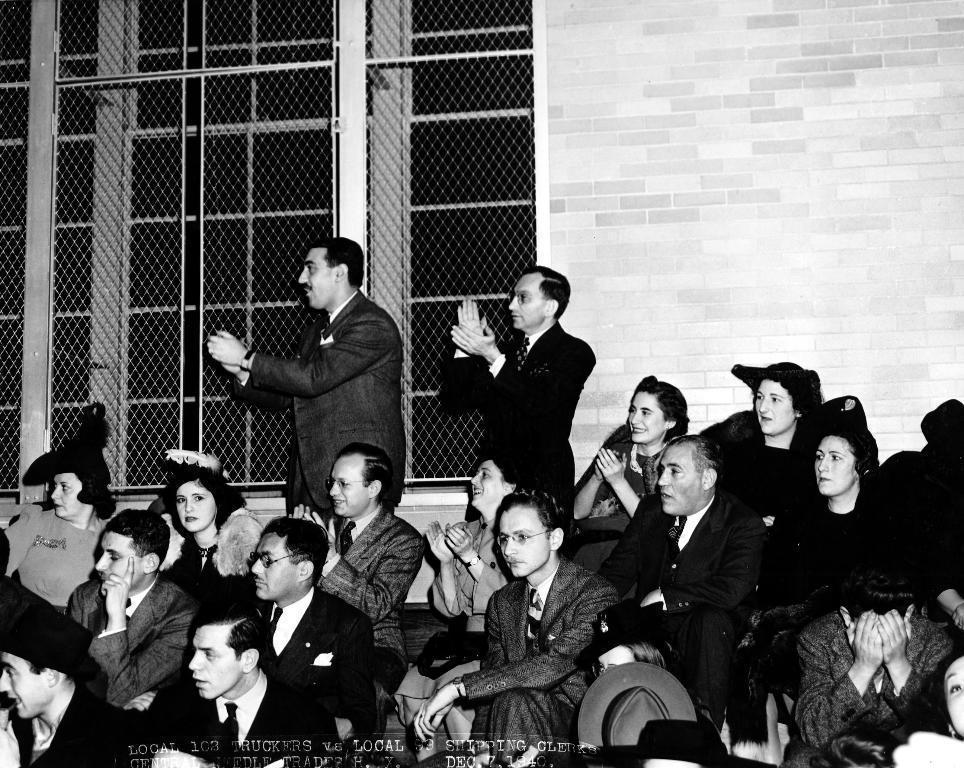How would you summarize this image in a sentence or two? In this image I can see group of people sitting and two persons standing. There is a wall and there are windows with mesh. At the bottom of the image there is a watermark. 